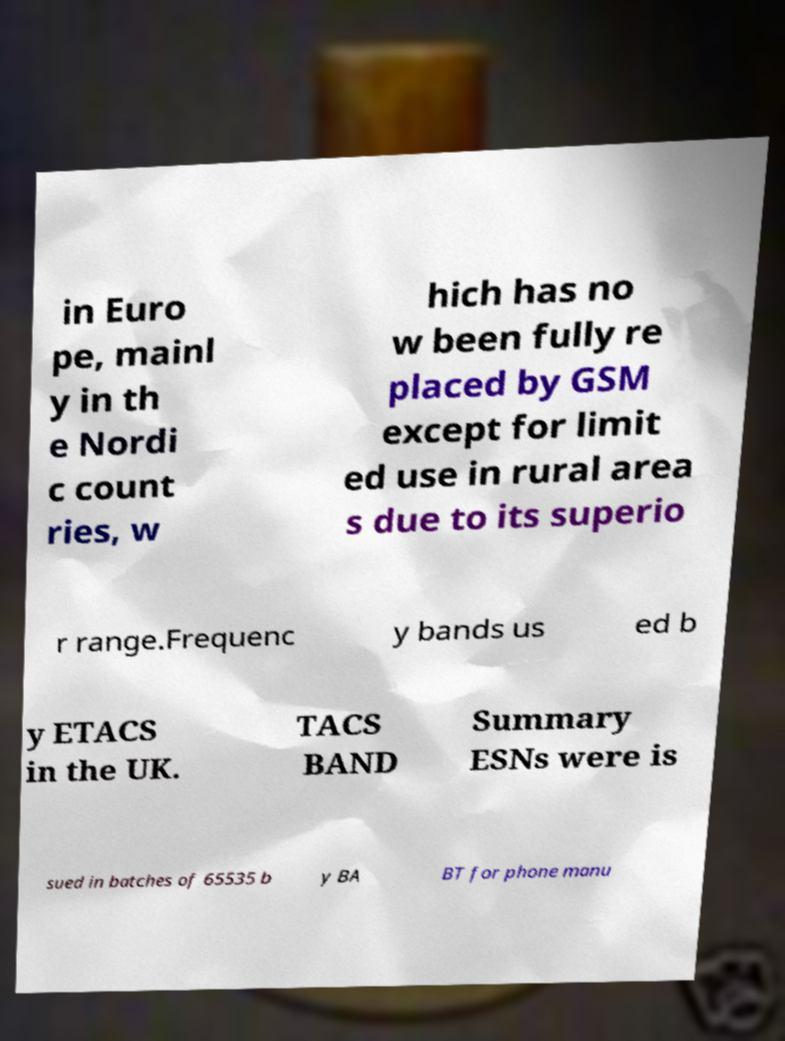Could you assist in decoding the text presented in this image and type it out clearly? in Euro pe, mainl y in th e Nordi c count ries, w hich has no w been fully re placed by GSM except for limit ed use in rural area s due to its superio r range.Frequenc y bands us ed b y ETACS in the UK. TACS BAND Summary ESNs were is sued in batches of 65535 b y BA BT for phone manu 